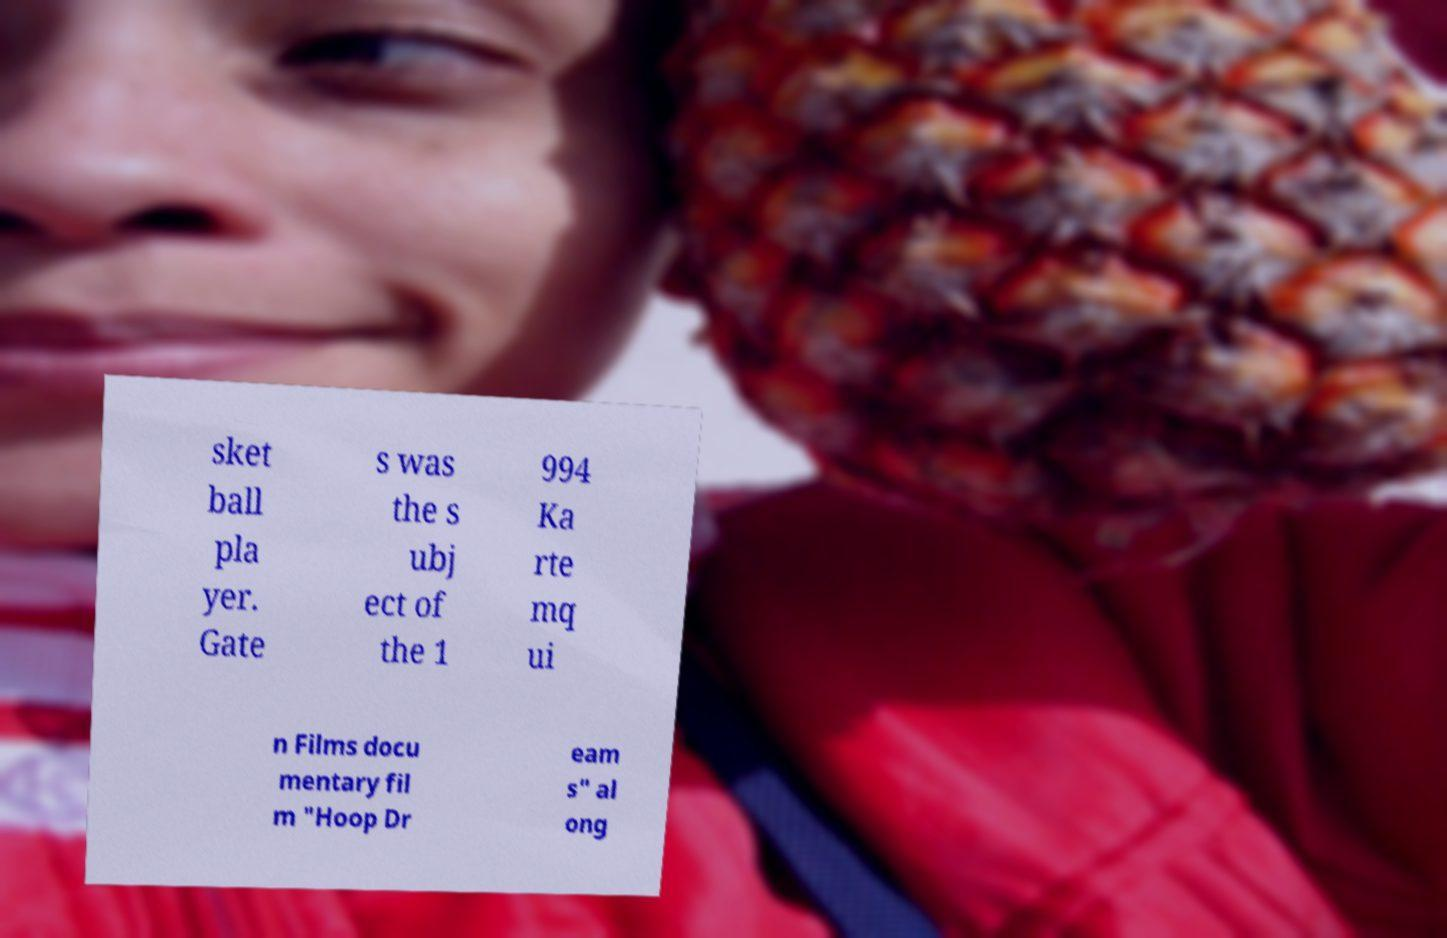Please read and relay the text visible in this image. What does it say? sket ball pla yer. Gate s was the s ubj ect of the 1 994 Ka rte mq ui n Films docu mentary fil m "Hoop Dr eam s" al ong 